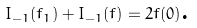<formula> <loc_0><loc_0><loc_500><loc_500>I _ { - 1 } ( f _ { 1 } ) + I _ { - 1 } ( f ) = 2 f ( 0 ) \text {.}</formula> 